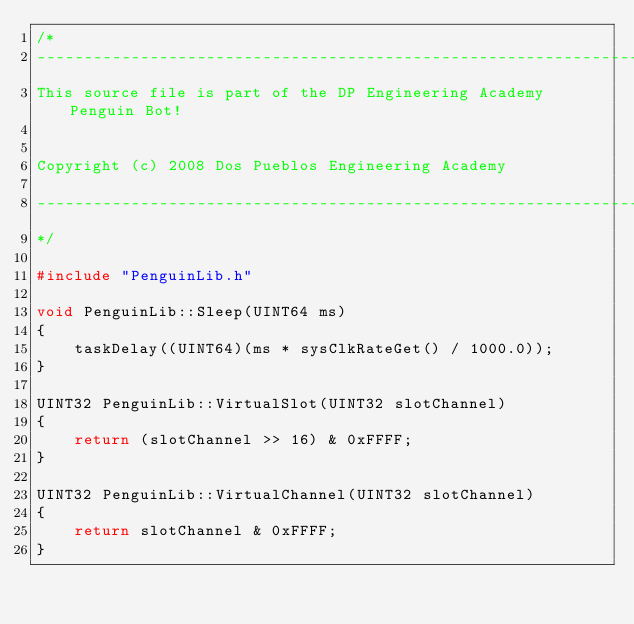Convert code to text. <code><loc_0><loc_0><loc_500><loc_500><_C++_>/*
---------------------------------------------------------------------------------------
This source file is part of the DP Engineering Academy Penguin Bot!


Copyright (c) 2008 Dos Pueblos Engineering Academy

---------------------------------------------------------------------------------------
*/

#include "PenguinLib.h"

void PenguinLib::Sleep(UINT64 ms)
{
	taskDelay((UINT64)(ms * sysClkRateGet() / 1000.0));
}

UINT32 PenguinLib::VirtualSlot(UINT32 slotChannel)
{
	return (slotChannel >> 16) & 0xFFFF;
}

UINT32 PenguinLib::VirtualChannel(UINT32 slotChannel)
{
	return slotChannel & 0xFFFF;
}
</code> 